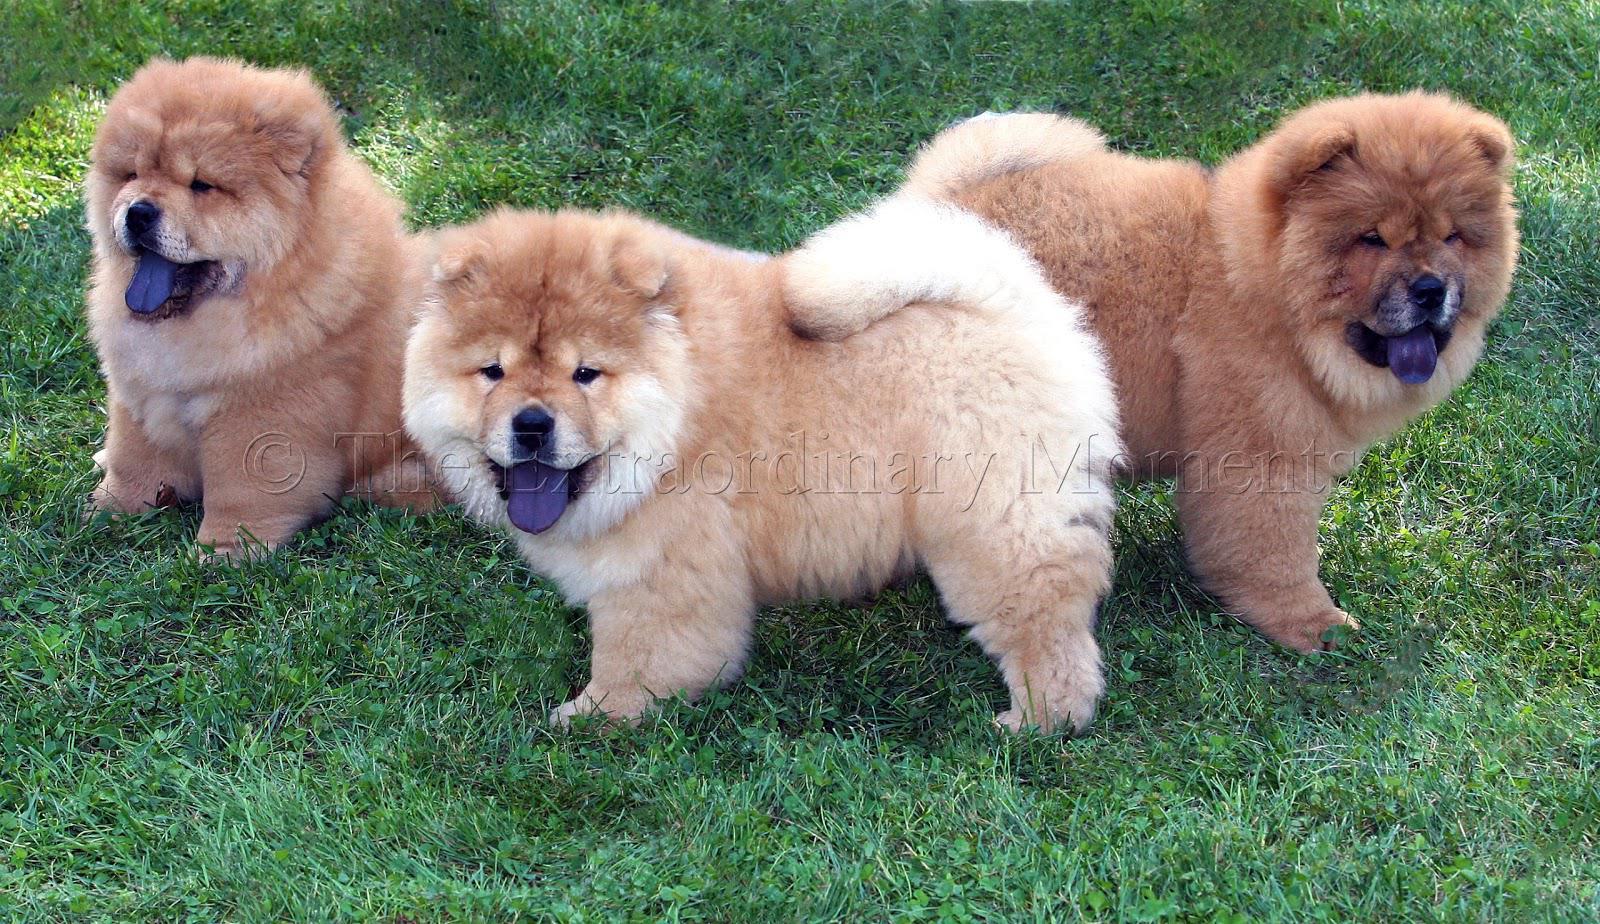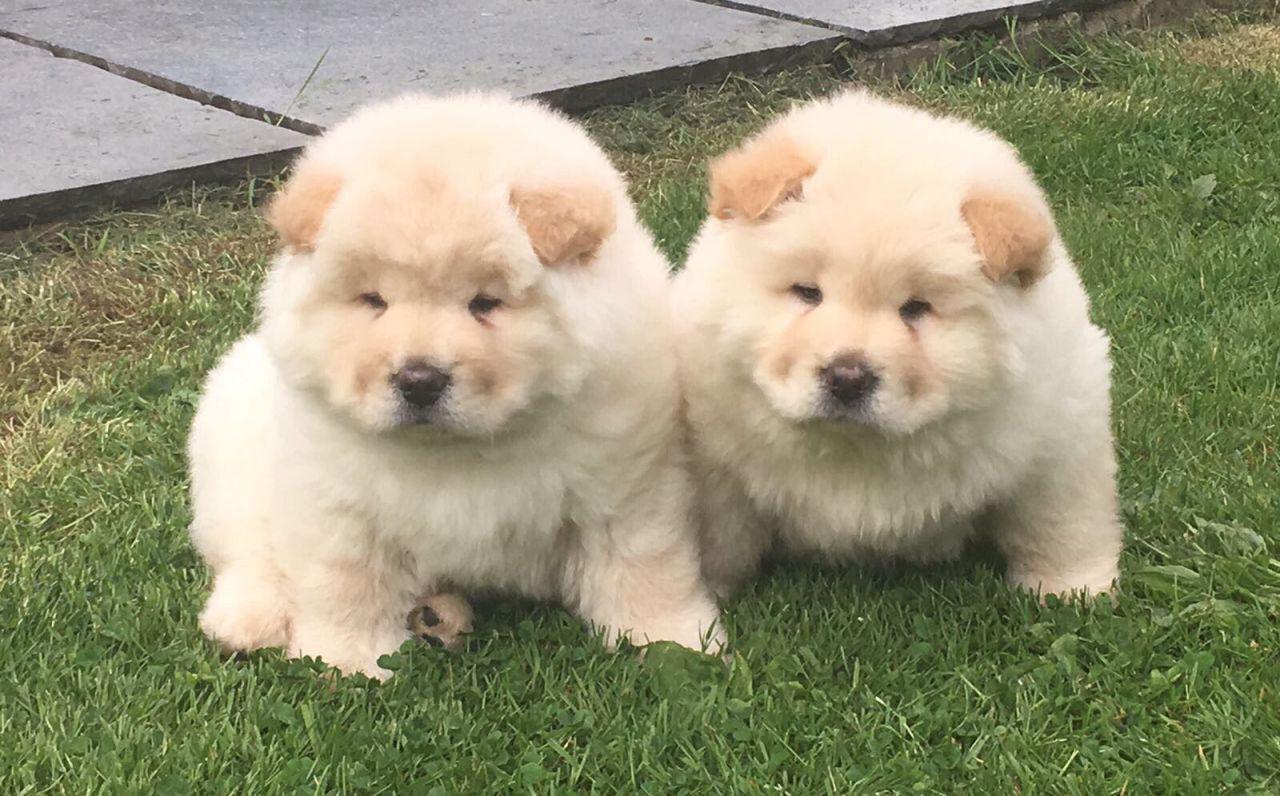The first image is the image on the left, the second image is the image on the right. Evaluate the accuracy of this statement regarding the images: "One image contains exactly two look-alike chow pups on green grass.". Is it true? Answer yes or no. Yes. The first image is the image on the left, the second image is the image on the right. Analyze the images presented: Is the assertion "There are two Chow Chows." valid? Answer yes or no. No. 